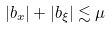Convert formula to latex. <formula><loc_0><loc_0><loc_500><loc_500>| b _ { x } | + | b _ { \xi } | \lesssim \mu</formula> 